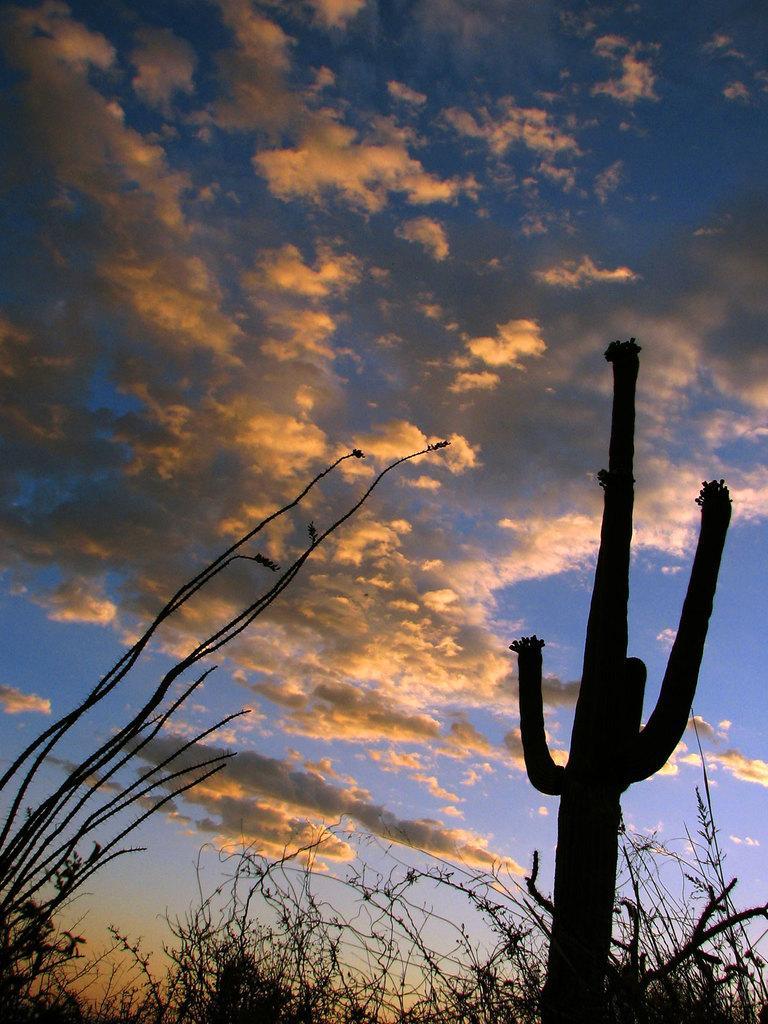Describe this image in one or two sentences. In this picture there are few plants and the sky is a bit cloudy. 